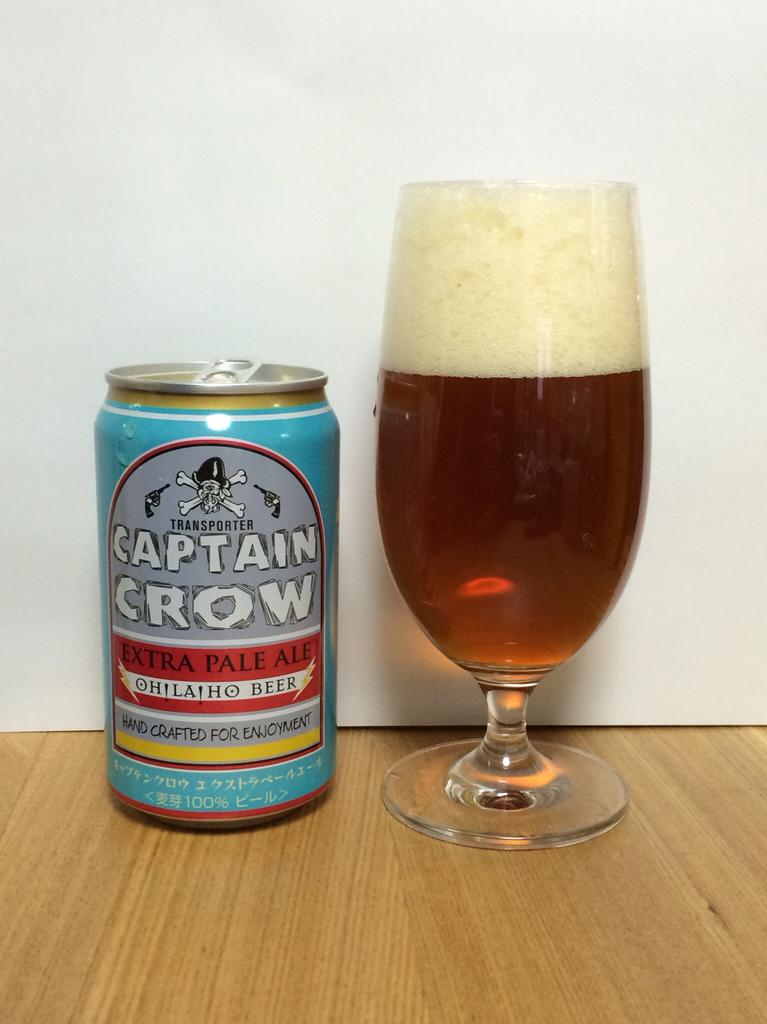<image>
Write a terse but informative summary of the picture. A can of Captain Crow beer is next to a full glass of beer. 